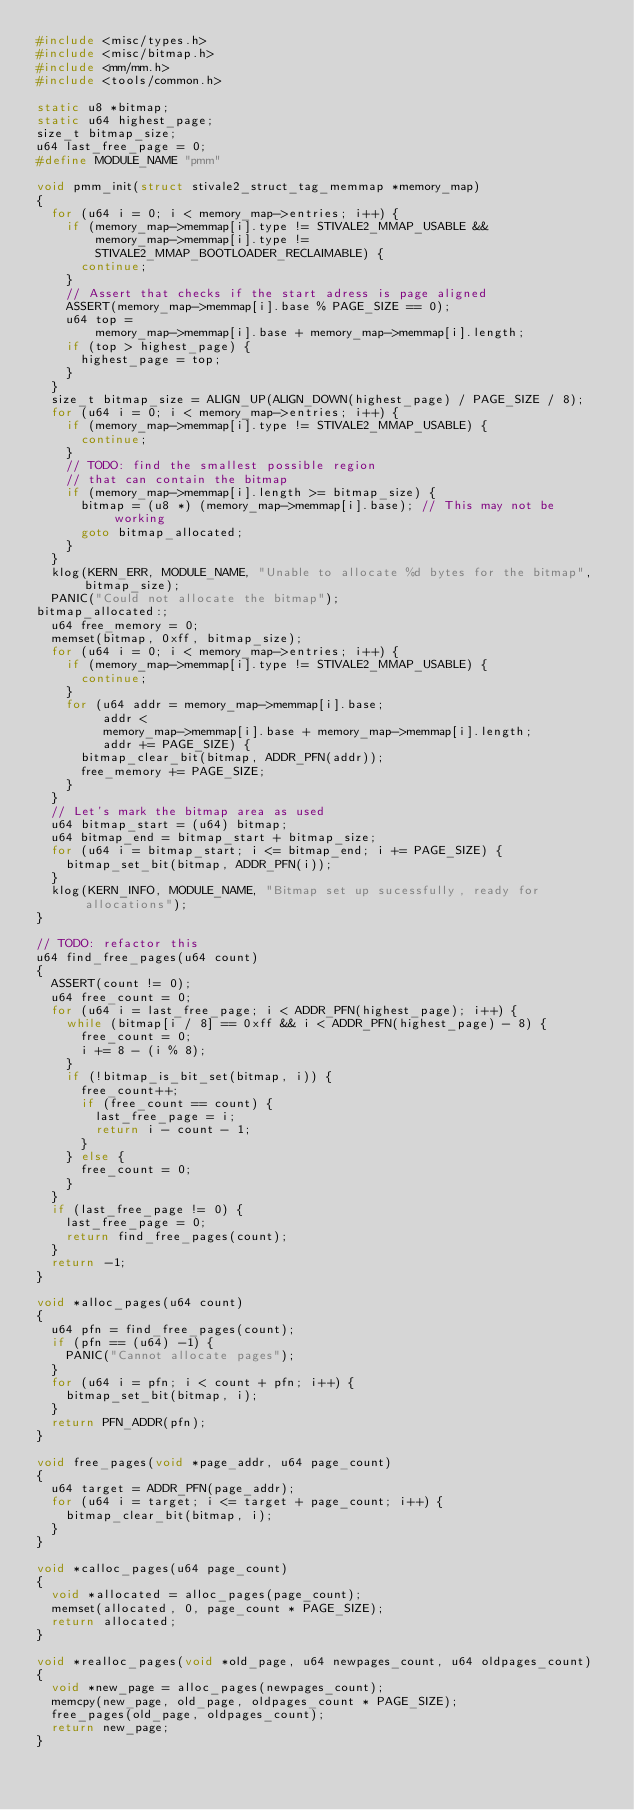Convert code to text. <code><loc_0><loc_0><loc_500><loc_500><_C_>#include <misc/types.h>
#include <misc/bitmap.h>
#include <mm/mm.h>
#include <tools/common.h>

static u8 *bitmap;
static u64 highest_page;
size_t bitmap_size;
u64 last_free_page = 0;
#define MODULE_NAME "pmm"

void pmm_init(struct stivale2_struct_tag_memmap *memory_map)
{
	for (u64 i = 0; i < memory_map->entries; i++) {
		if (memory_map->memmap[i].type != STIVALE2_MMAP_USABLE &&
		    memory_map->memmap[i].type !=
		    STIVALE2_MMAP_BOOTLOADER_RECLAIMABLE) {
			continue;
		}
		// Assert that checks if the start adress is page aligned
		ASSERT(memory_map->memmap[i].base % PAGE_SIZE == 0);
		u64 top =
		    memory_map->memmap[i].base + memory_map->memmap[i].length;
		if (top > highest_page) {
			highest_page = top;
		}
	}
	size_t bitmap_size = ALIGN_UP(ALIGN_DOWN(highest_page) / PAGE_SIZE / 8);
	for (u64 i = 0; i < memory_map->entries; i++) {
		if (memory_map->memmap[i].type != STIVALE2_MMAP_USABLE) {
			continue;
		}
		// TODO: find the smallest possible region
		// that can contain the bitmap
		if (memory_map->memmap[i].length >= bitmap_size) {
			bitmap = (u8 *) (memory_map->memmap[i].base);	// This may not be working
			goto bitmap_allocated;
		}
	}
	klog(KERN_ERR, MODULE_NAME, "Unable to allocate %d bytes for the bitmap", bitmap_size);
	PANIC("Could not allocate the bitmap");
bitmap_allocated:;
	u64 free_memory = 0;
	memset(bitmap, 0xff, bitmap_size);
	for (u64 i = 0; i < memory_map->entries; i++) {
		if (memory_map->memmap[i].type != STIVALE2_MMAP_USABLE) {
			continue;
		}
		for (u64 addr = memory_map->memmap[i].base;
		     addr <
		     memory_map->memmap[i].base + memory_map->memmap[i].length;
		     addr += PAGE_SIZE) {
			bitmap_clear_bit(bitmap, ADDR_PFN(addr));
			free_memory += PAGE_SIZE;
		}
	}
	// Let's mark the bitmap area as used
	u64 bitmap_start = (u64) bitmap;
	u64 bitmap_end = bitmap_start + bitmap_size;
	for (u64 i = bitmap_start; i <= bitmap_end; i += PAGE_SIZE) {
		bitmap_set_bit(bitmap, ADDR_PFN(i));
	}
	klog(KERN_INFO, MODULE_NAME, "Bitmap set up sucessfully, ready for allocations");
}

// TODO: refactor this
u64 find_free_pages(u64 count)
{
	ASSERT(count != 0);
	u64 free_count = 0;
	for (u64 i = last_free_page; i < ADDR_PFN(highest_page); i++) {
		while (bitmap[i / 8] == 0xff && i < ADDR_PFN(highest_page) - 8) {
			free_count = 0;
			i += 8 - (i % 8);
		}
		if (!bitmap_is_bit_set(bitmap, i)) {
			free_count++;
			if (free_count == count) {
				last_free_page = i;
				return i - count - 1;
			}
		} else {
			free_count = 0;
		}
	}
	if (last_free_page != 0) {
		last_free_page = 0;
		return find_free_pages(count);
	}
	return -1;
}

void *alloc_pages(u64 count)
{
	u64 pfn = find_free_pages(count);
	if (pfn == (u64) -1) {
		PANIC("Cannot allocate pages");
	}
	for (u64 i = pfn; i < count + pfn; i++) {
		bitmap_set_bit(bitmap, i);
	}
	return PFN_ADDR(pfn);
}

void free_pages(void *page_addr, u64 page_count)
{
	u64 target = ADDR_PFN(page_addr);
	for (u64 i = target; i <= target + page_count; i++) {
		bitmap_clear_bit(bitmap, i);
	}
}

void *calloc_pages(u64 page_count)
{
	void *allocated = alloc_pages(page_count);
	memset(allocated, 0, page_count * PAGE_SIZE);
	return allocated;
}

void *realloc_pages(void *old_page, u64 newpages_count, u64 oldpages_count)
{
	void *new_page = alloc_pages(newpages_count);
	memcpy(new_page, old_page, oldpages_count * PAGE_SIZE);
	free_pages(old_page, oldpages_count);
	return new_page;
}
</code> 